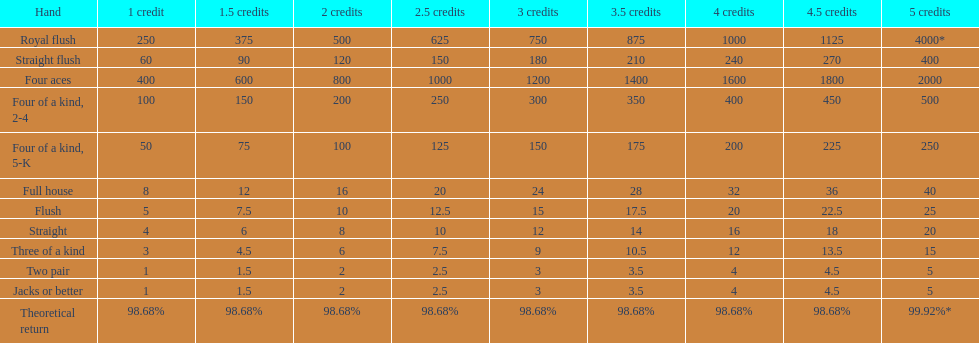Can a 2-credit full house be compared to a 5-credit three of a kind in terms of value? No. 